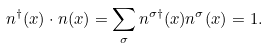Convert formula to latex. <formula><loc_0><loc_0><loc_500><loc_500>n ^ { \dagger } ( x ) \cdot n ( x ) = \sum _ { \sigma } n ^ { \sigma \dagger } ( x ) n ^ { \sigma } ( x ) = 1 .</formula> 